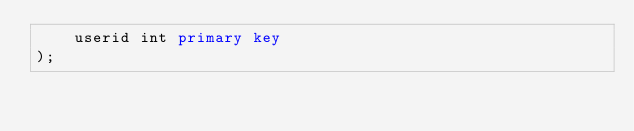<code> <loc_0><loc_0><loc_500><loc_500><_SQL_>    userid int primary key
);</code> 